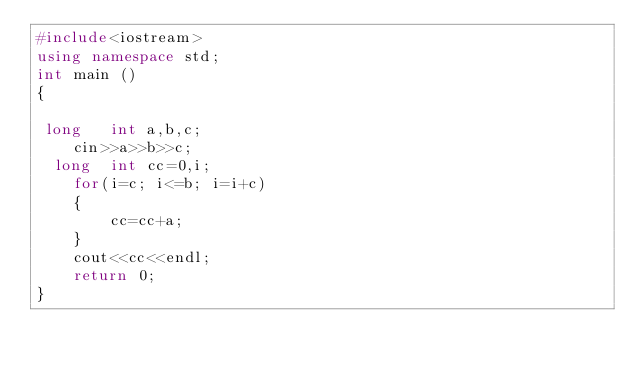<code> <loc_0><loc_0><loc_500><loc_500><_C++_>#include<iostream>
using namespace std;
int main ()
{

 long   int a,b,c;
    cin>>a>>b>>c;
  long  int cc=0,i;
    for(i=c; i<=b; i=i+c)
    {
        cc=cc+a;
    }
    cout<<cc<<endl;
    return 0;
}
</code> 